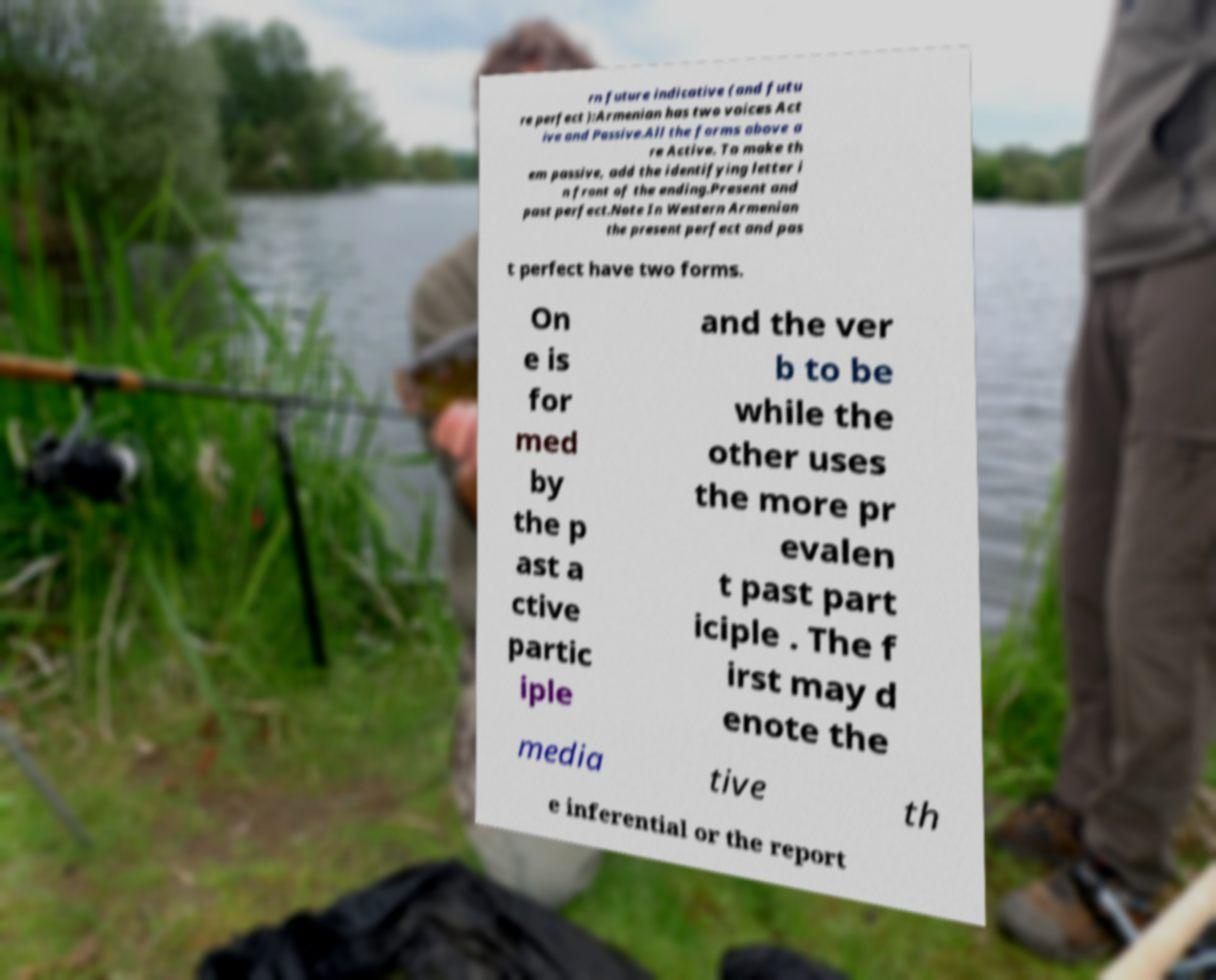Can you read and provide the text displayed in the image?This photo seems to have some interesting text. Can you extract and type it out for me? rn future indicative (and futu re perfect ):Armenian has two voices Act ive and Passive.All the forms above a re Active. To make th em passive, add the identifying letter i n front of the ending.Present and past perfect.Note In Western Armenian the present perfect and pas t perfect have two forms. On e is for med by the p ast a ctive partic iple and the ver b to be while the other uses the more pr evalen t past part iciple . The f irst may d enote the media tive th e inferential or the report 